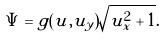<formula> <loc_0><loc_0><loc_500><loc_500>\Psi = g ( u , u _ { y } ) \sqrt { u _ { x } ^ { 2 } + 1 } .</formula> 